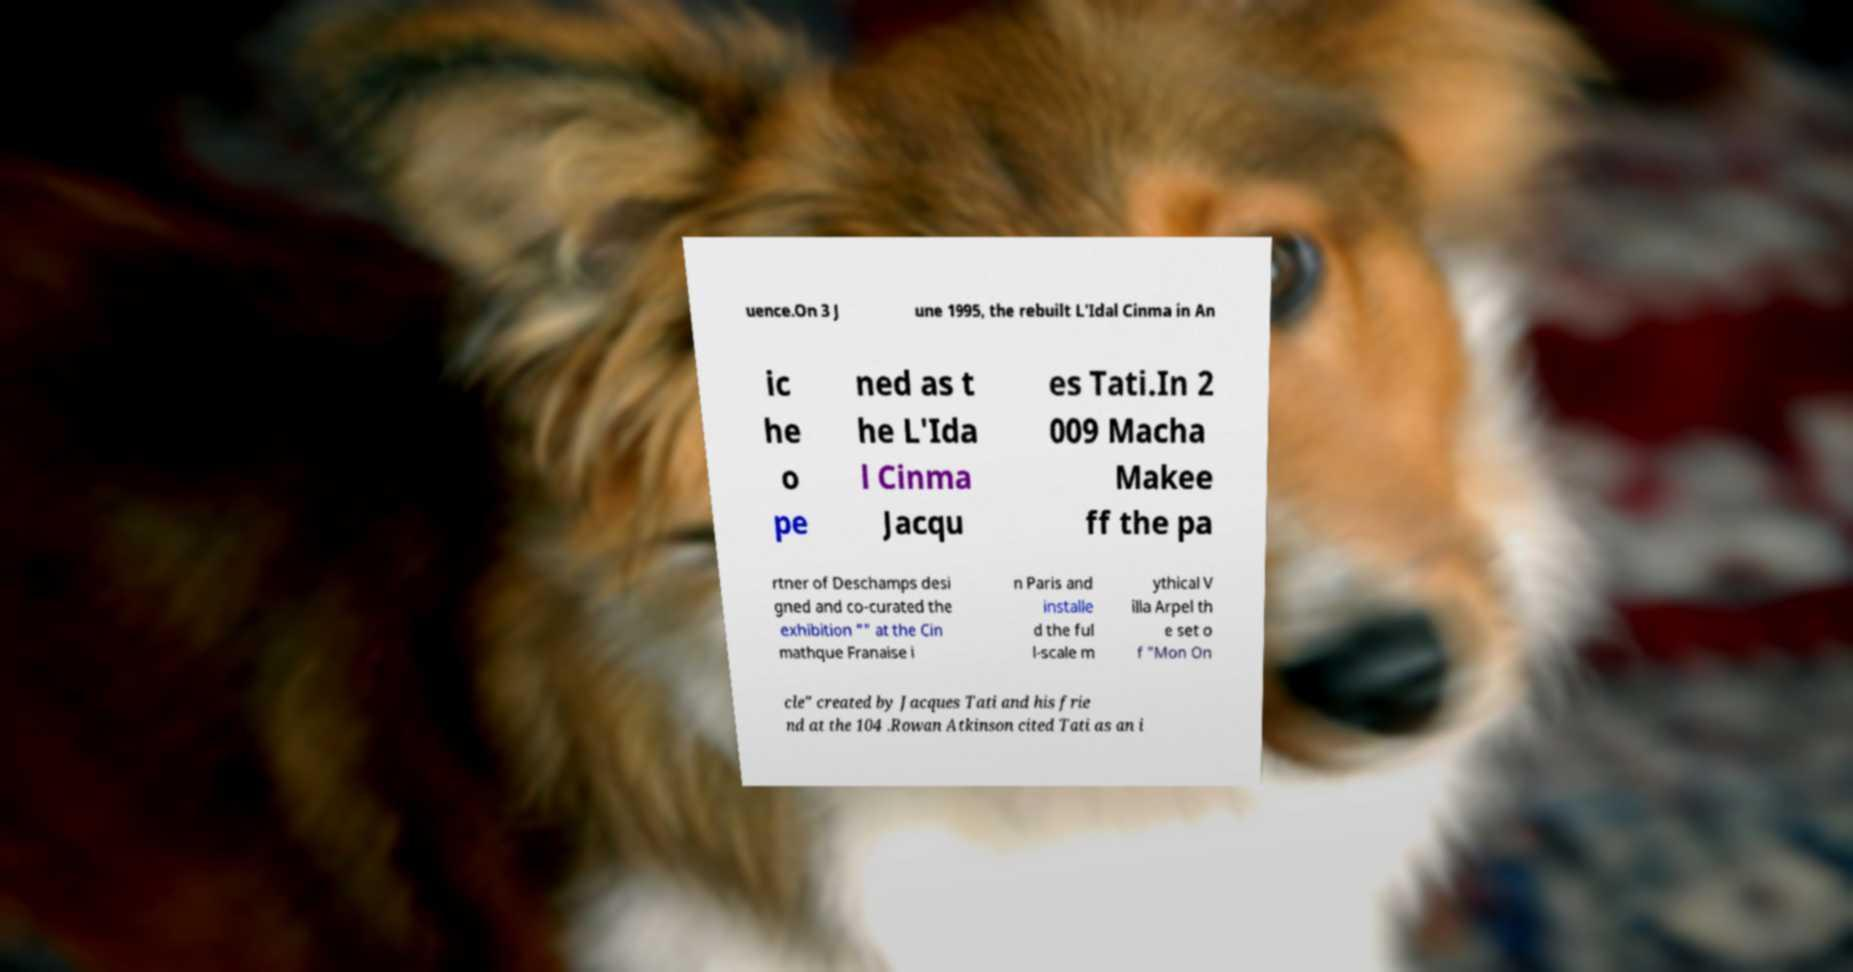I need the written content from this picture converted into text. Can you do that? uence.On 3 J une 1995, the rebuilt L'Idal Cinma in An ic he o pe ned as t he L'Ida l Cinma Jacqu es Tati.In 2 009 Macha Makee ff the pa rtner of Deschamps desi gned and co-curated the exhibition "" at the Cin mathque Franaise i n Paris and installe d the ful l-scale m ythical V illa Arpel th e set o f "Mon On cle" created by Jacques Tati and his frie nd at the 104 .Rowan Atkinson cited Tati as an i 